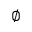<formula> <loc_0><loc_0><loc_500><loc_500>\varnothing</formula> 